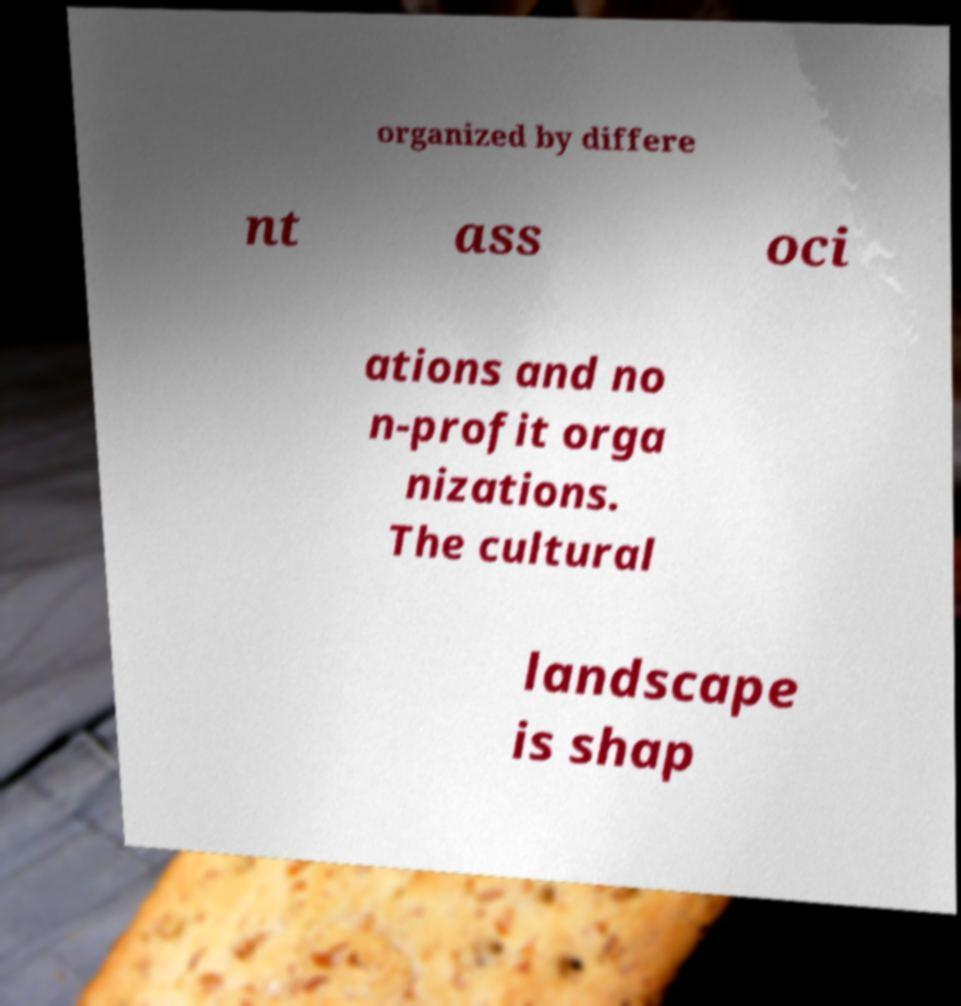Please identify and transcribe the text found in this image. organized by differe nt ass oci ations and no n-profit orga nizations. The cultural landscape is shap 